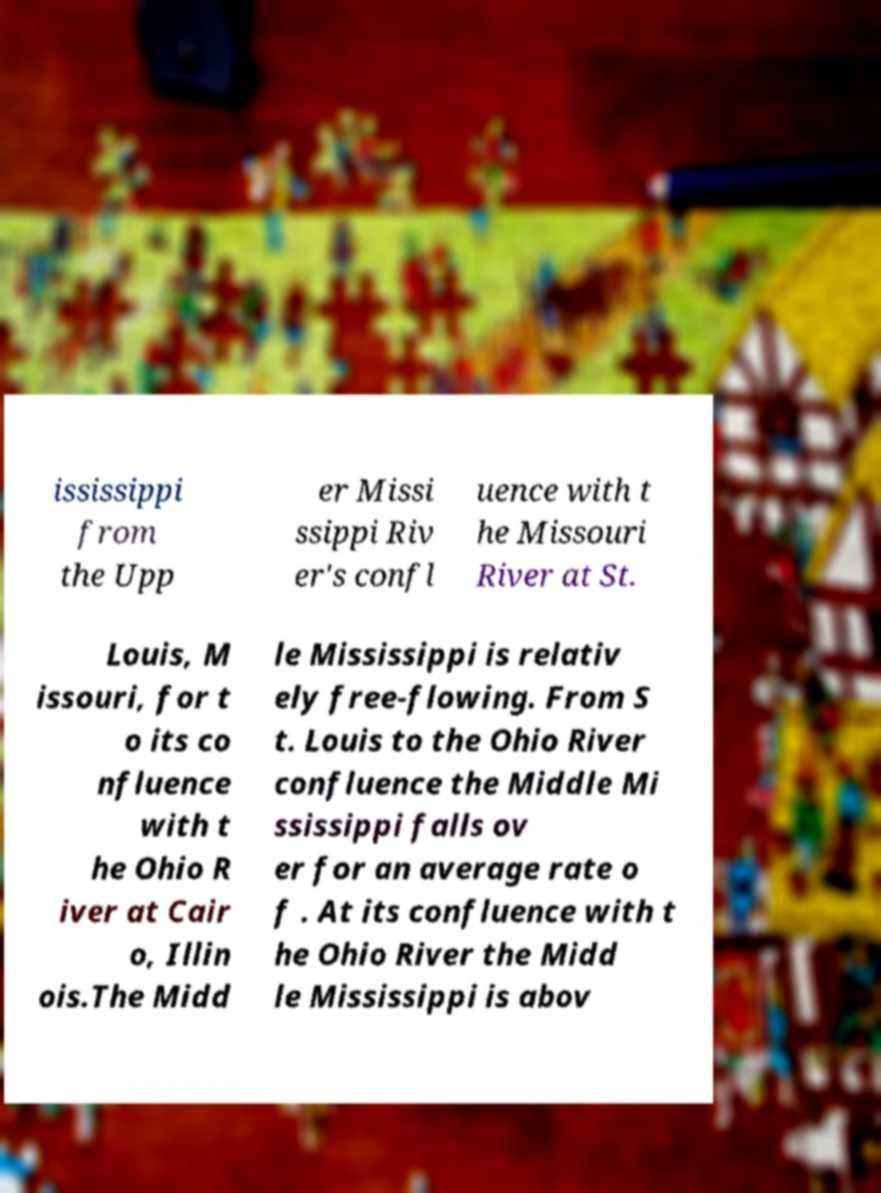What messages or text are displayed in this image? I need them in a readable, typed format. ississippi from the Upp er Missi ssippi Riv er's confl uence with t he Missouri River at St. Louis, M issouri, for t o its co nfluence with t he Ohio R iver at Cair o, Illin ois.The Midd le Mississippi is relativ ely free-flowing. From S t. Louis to the Ohio River confluence the Middle Mi ssissippi falls ov er for an average rate o f . At its confluence with t he Ohio River the Midd le Mississippi is abov 